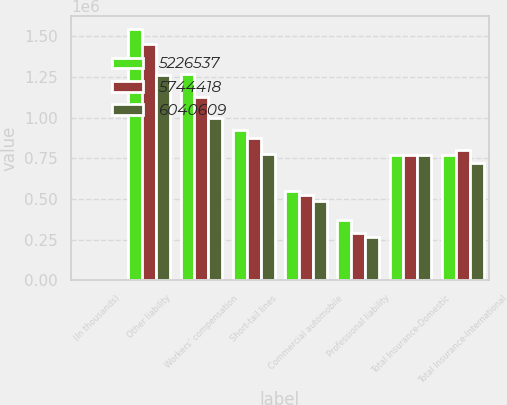<chart> <loc_0><loc_0><loc_500><loc_500><stacked_bar_chart><ecel><fcel>(In thousands)<fcel>Other liability<fcel>Workers' compensation<fcel>Short-tail lines<fcel>Commercial automobile<fcel>Professional liability<fcel>Total Insurance-Domestic<fcel>Total Insurance-International<nl><fcel>5.22654e+06<fcel>2015<fcel>1.54616e+06<fcel>1.26978e+06<fcel>925468<fcel>548450<fcel>369499<fcel>772141<fcel>772141<nl><fcel>5.74442e+06<fcel>2014<fcel>1.44942e+06<fcel>1.1267e+06<fcel>875898<fcel>526344<fcel>293562<fcel>772141<fcel>802375<nl><fcel>6.04061e+06<fcel>2013<fcel>1.25938e+06<fcel>995047<fcel>774809<fcel>486759<fcel>266425<fcel>772141<fcel>723151<nl></chart> 